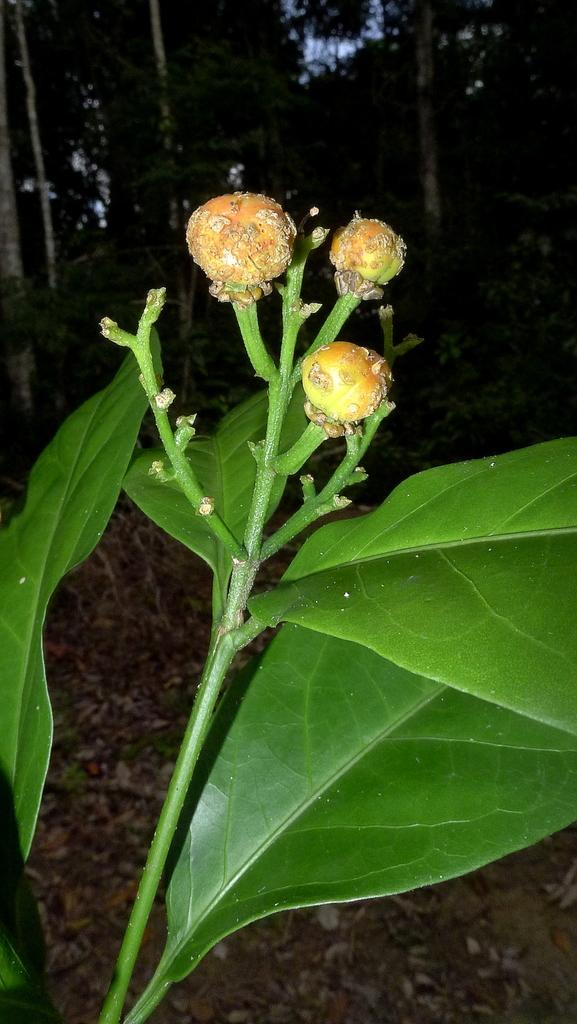What is growing on the plant in the image? There are buds on a plant in the image. What can be seen in the background of the image? There are many trees and the sky visible in the background of the image. What type of oil can be seen dripping from the buds in the image? There is no oil present in the image; it features a plant with buds and a background of trees and sky. 